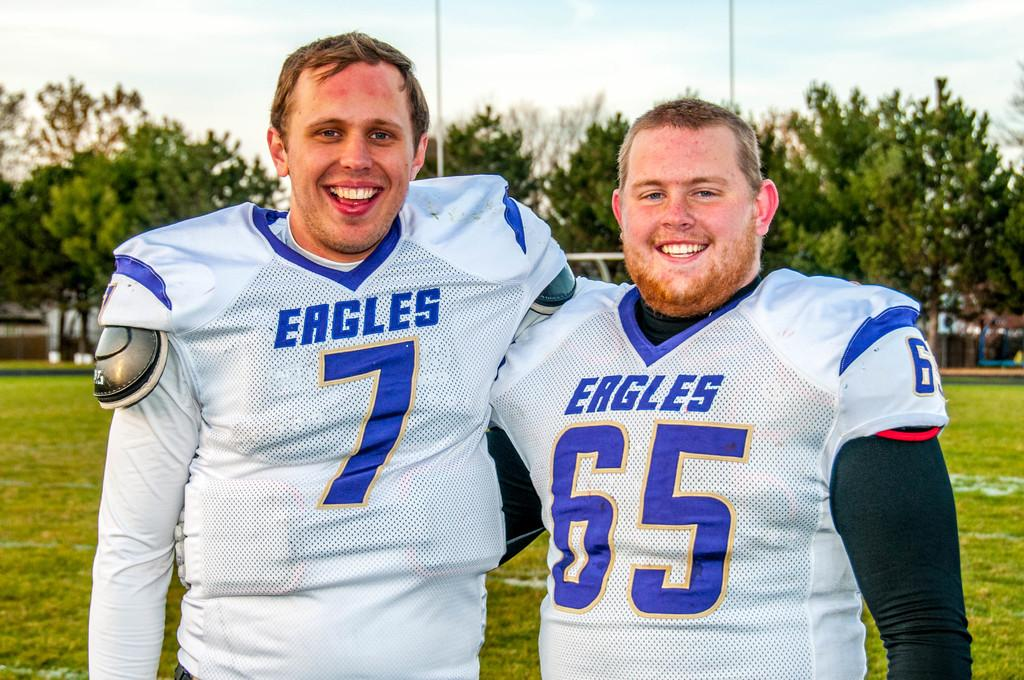Who is present in the image? There are men in the image. What expression do the men have? The men are smiling. What type of vegetation can be seen in the image? There are trees in the image. What structures are present in the image? There are poles in the image. What is the ground covered with in the image? The ground is covered with grass. How would you describe the sky in the image? The sky is blue and cloudy. What type of skirt is the mother wearing in the image? There is no mother or skirt present in the image; it features men with smiling expressions. 